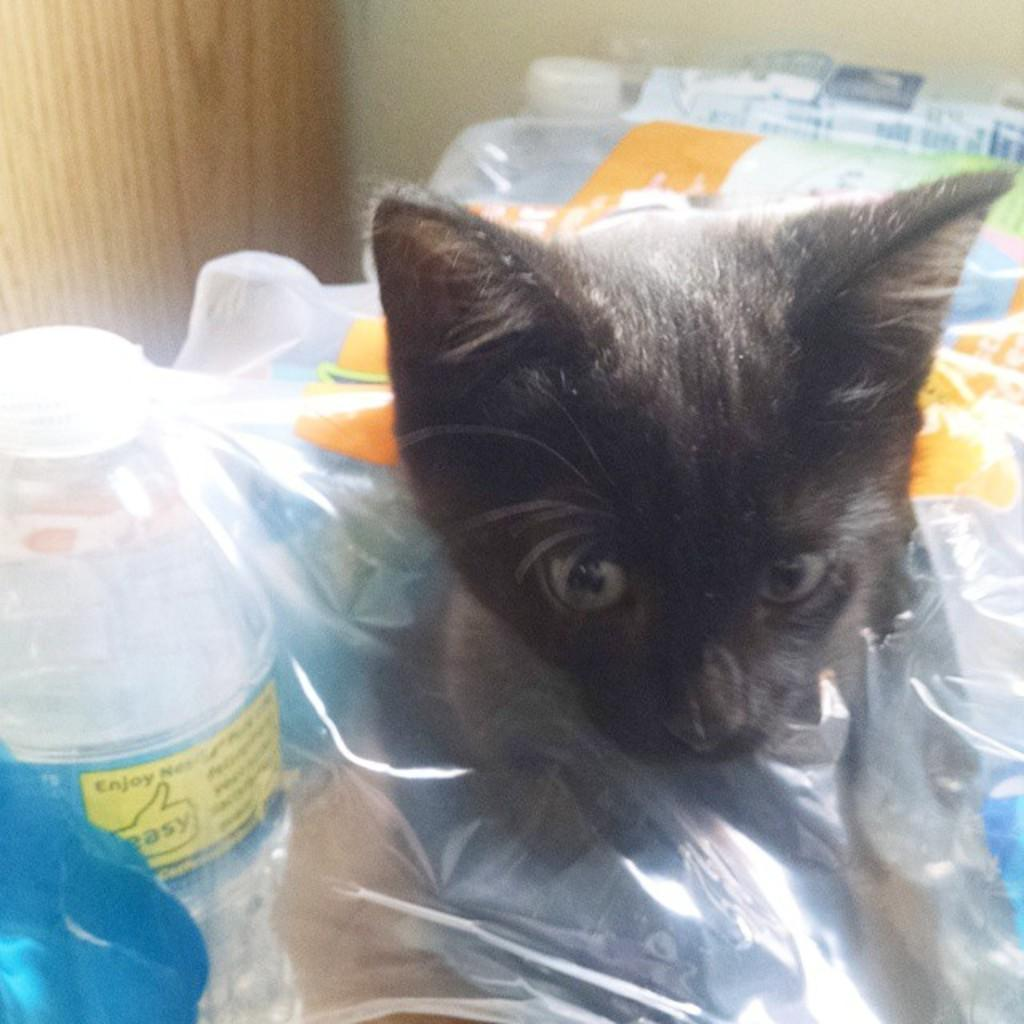What type of animal is in the image? There is a cat in the image. What objects are present in the image that might be used for protection or covering? There are plastic covers in the image. What type of containers can be seen in the image? There are bottles in the image. What material is used for the object in the image? There is a wooden object in the image. What is visible in the background of the image? There is a wall in the background of the image. What type of bird is perched on the wooden object in the image? There is no bird present in the image; it only features a cat, plastic covers, bottles, and a wooden object. 